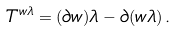Convert formula to latex. <formula><loc_0><loc_0><loc_500><loc_500>T ^ { w \lambda } = ( \partial w ) \lambda - \partial ( w \lambda ) \, .</formula> 